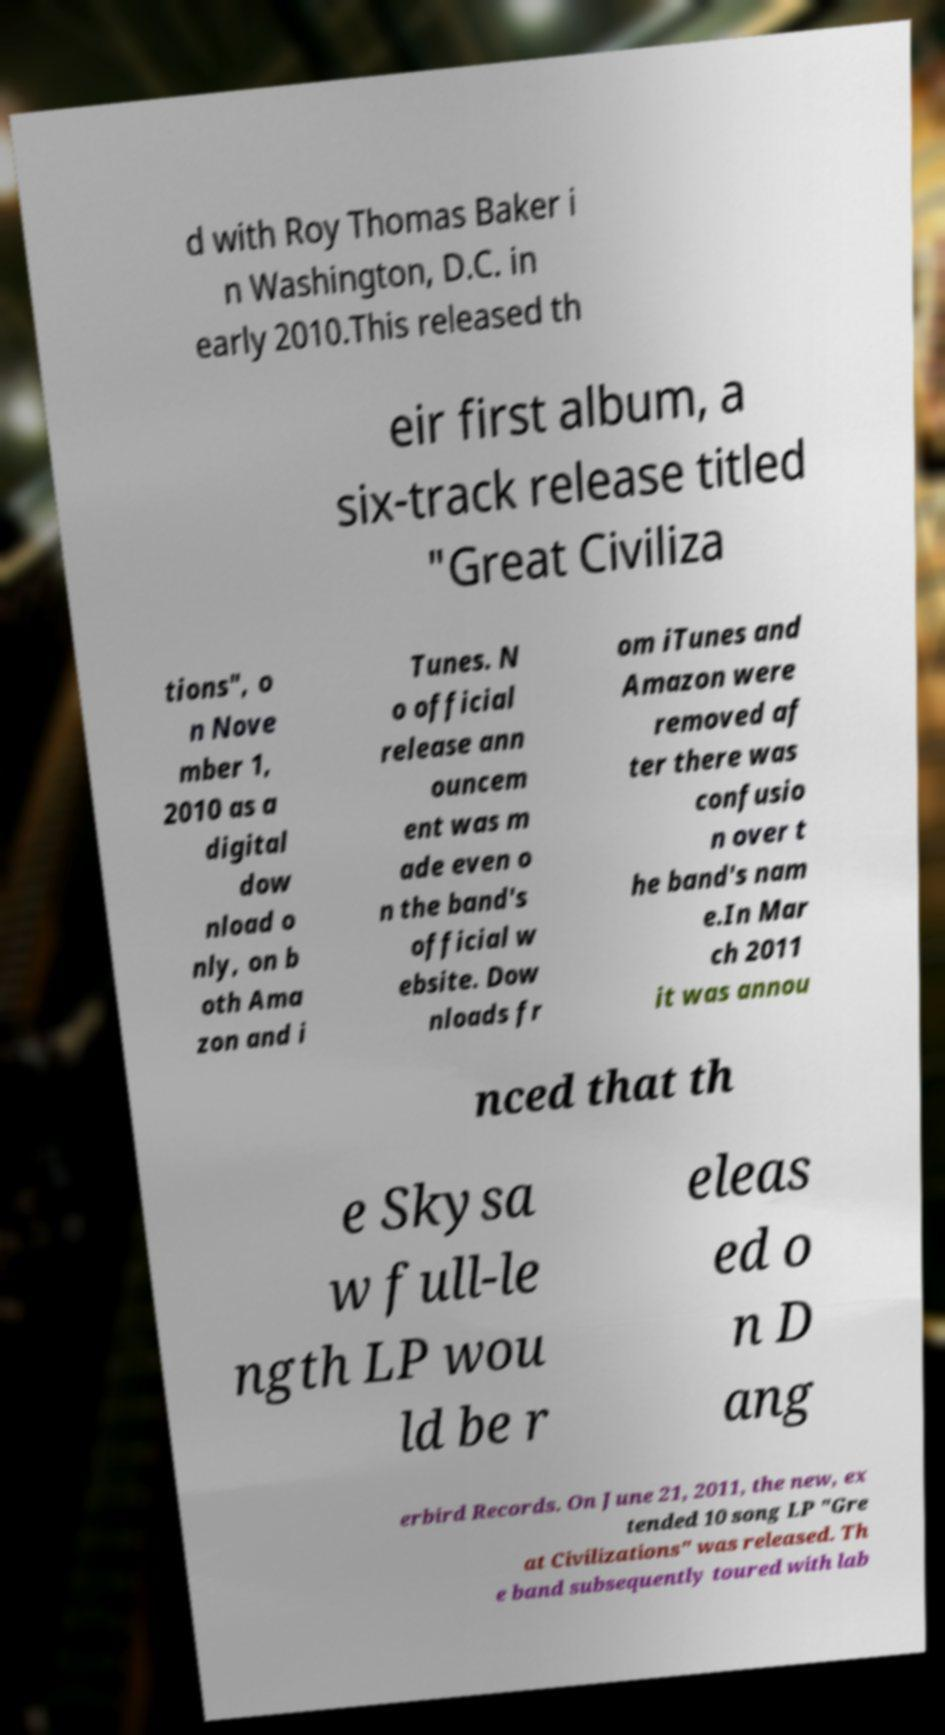What messages or text are displayed in this image? I need them in a readable, typed format. d with Roy Thomas Baker i n Washington, D.C. in early 2010.This released th eir first album, a six-track release titled "Great Civiliza tions", o n Nove mber 1, 2010 as a digital dow nload o nly, on b oth Ama zon and i Tunes. N o official release ann ouncem ent was m ade even o n the band's official w ebsite. Dow nloads fr om iTunes and Amazon were removed af ter there was confusio n over t he band's nam e.In Mar ch 2011 it was annou nced that th e Skysa w full-le ngth LP wou ld be r eleas ed o n D ang erbird Records. On June 21, 2011, the new, ex tended 10 song LP "Gre at Civilizations" was released. Th e band subsequently toured with lab 